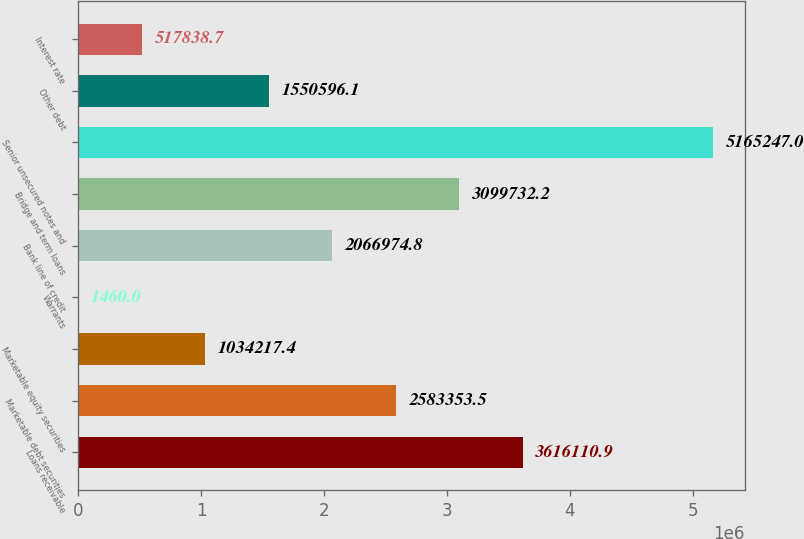Convert chart to OTSL. <chart><loc_0><loc_0><loc_500><loc_500><bar_chart><fcel>Loans receivable<fcel>Marketable debt securities<fcel>Marketable equity securities<fcel>Warrants<fcel>Bank line of credit<fcel>Bridge and term loans<fcel>Senior unsecured notes and<fcel>Other debt<fcel>Interest rate<nl><fcel>3.61611e+06<fcel>2.58335e+06<fcel>1.03422e+06<fcel>1460<fcel>2.06697e+06<fcel>3.09973e+06<fcel>5.16525e+06<fcel>1.5506e+06<fcel>517839<nl></chart> 